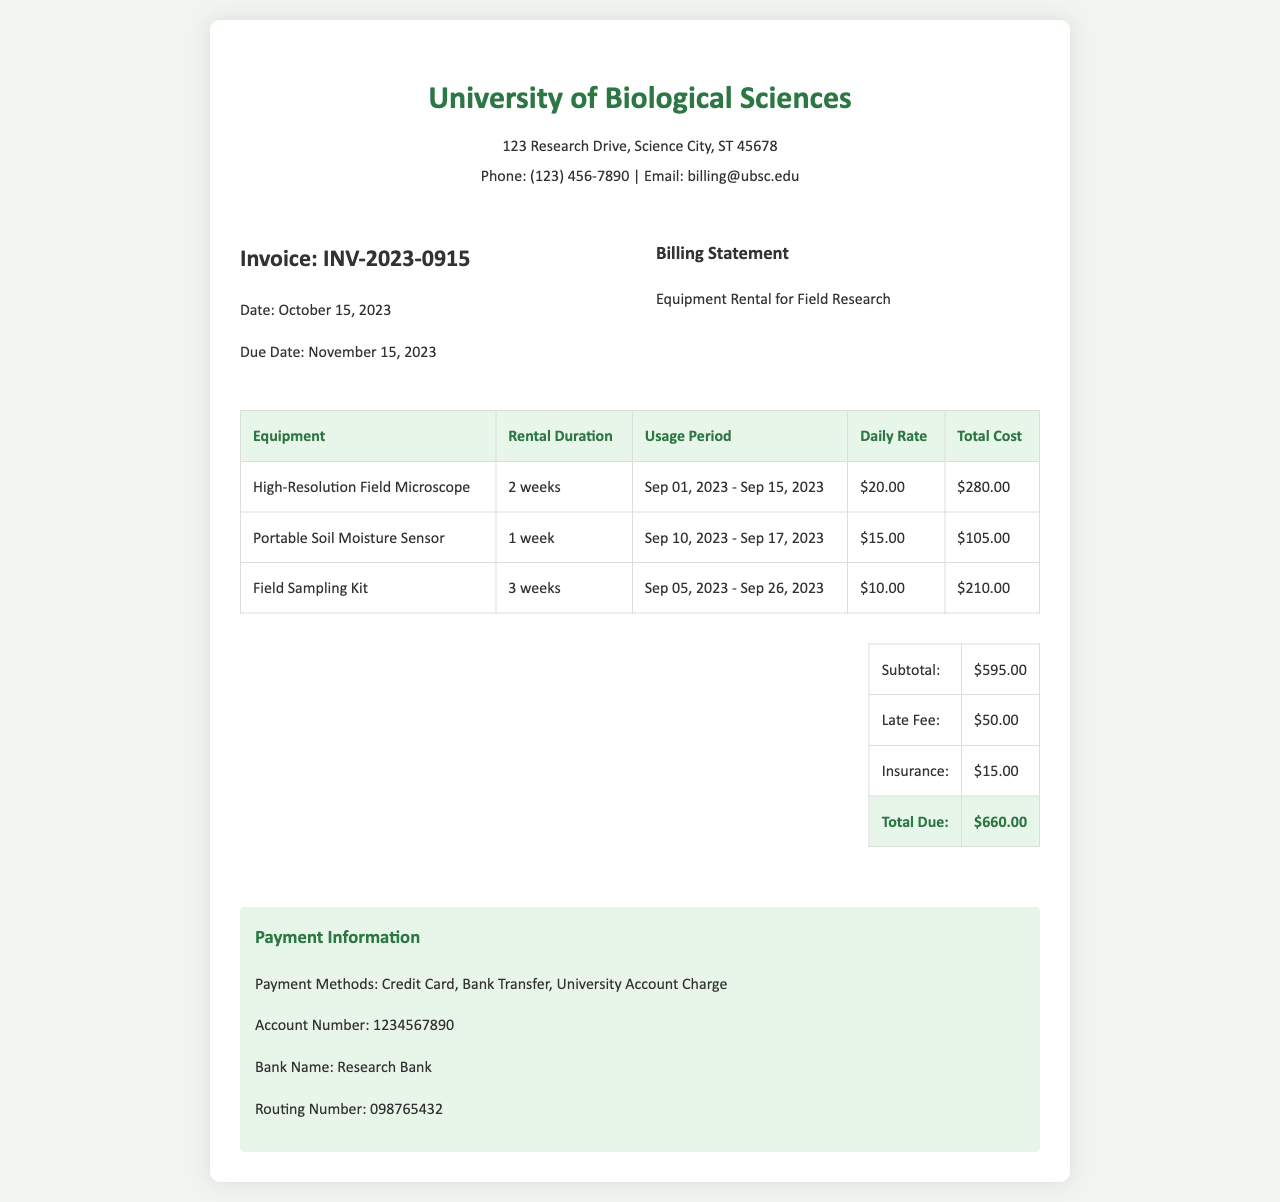what is the invoice number? The invoice number can be found in the document as INV-2023-0915.
Answer: INV-2023-0915 what is the due date of the invoice? The due date is specified in the document, which is November 15, 2023.
Answer: November 15, 2023 how many weeks was the High-Resolution Field Microscope rented for? The rental duration for this equipment is stated as 2 weeks in the document.
Answer: 2 weeks what is the total cost for the Portable Soil Moisture Sensor? The total cost for this equipment is listed as $105.00 in the invoice.
Answer: $105.00 what is the subtotal amount before any additional fees? The subtotal amount before any fees is provided as $595.00 in the document.
Answer: $595.00 which equipment had the longest rental duration? The Field Sampling Kit was rented for the longest duration of 3 weeks.
Answer: Field Sampling Kit what is the amount of the late fee? The late fee is explicitly mentioned as $50.00 in the document.
Answer: $50.00 how many different payment methods are listed in the document? The document states three distinct payment methods are available.
Answer: 3 